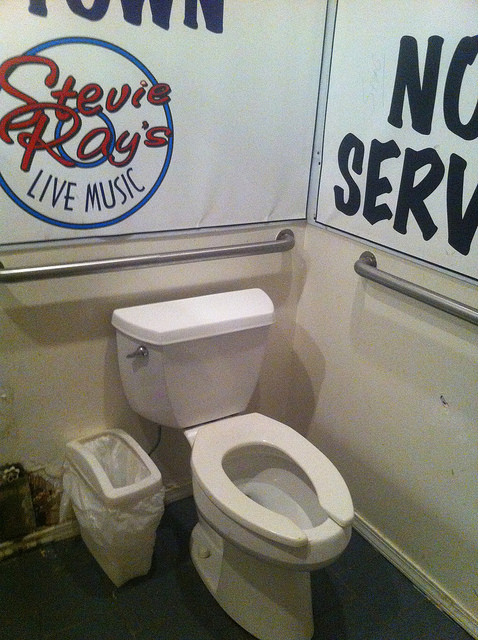Please identify all text content in this image. Stevie Rays LIVE MUSIC NO SERV 